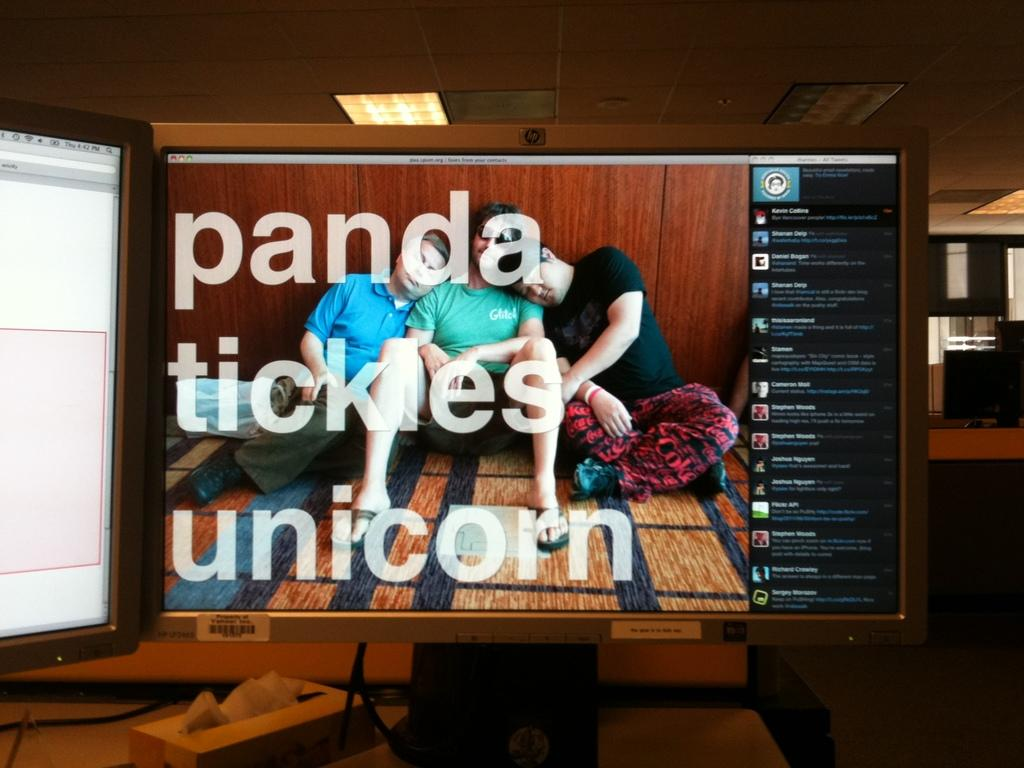<image>
Describe the image concisely. A computer monitor screen displaying people sitting on a carpet with the font displaying, "panda tickles unicorn". 